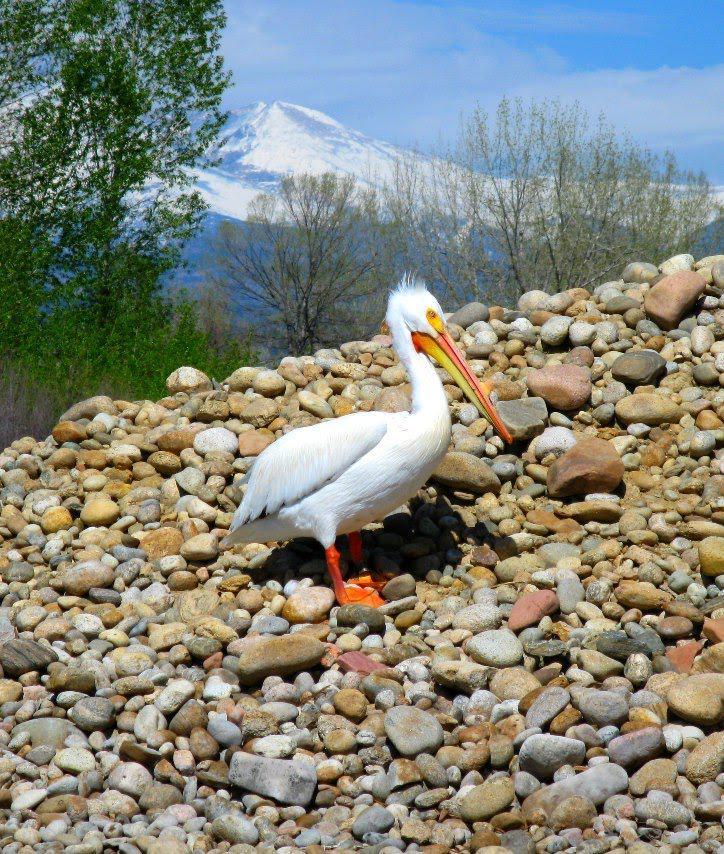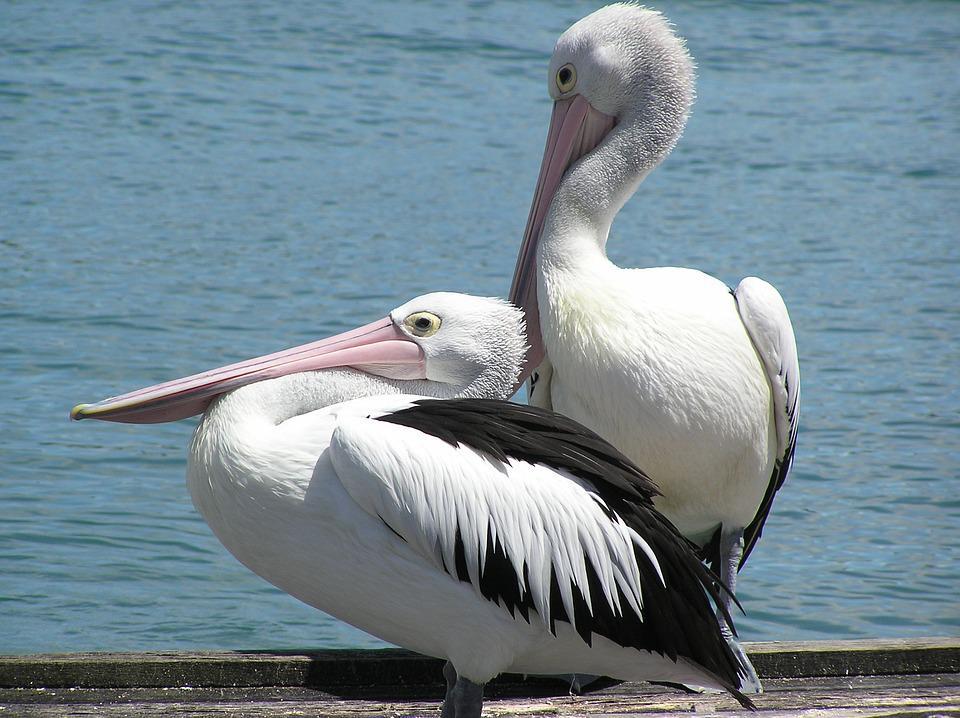The first image is the image on the left, the second image is the image on the right. Given the left and right images, does the statement "There is at least one image of one or more pelicans standing on a dock." hold true? Answer yes or no. Yes. The first image is the image on the left, the second image is the image on the right. For the images shown, is this caption "There is an animal directly on top of a wooden post." true? Answer yes or no. No. 